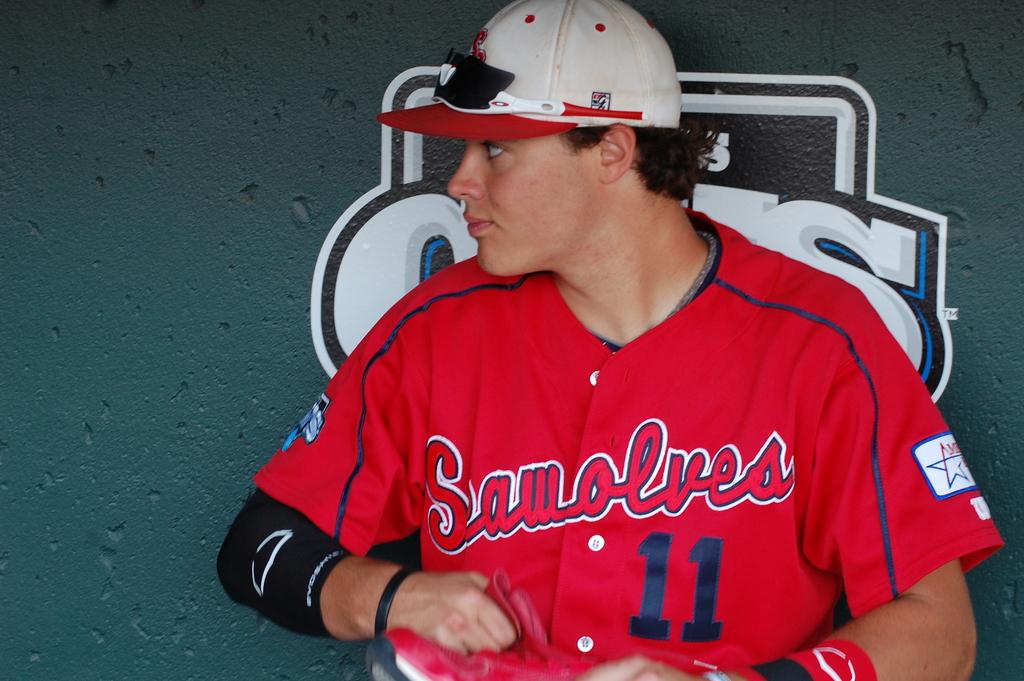What is the man in red team number?
Give a very brief answer. 11. What is the team name?
Your answer should be compact. Sawolves. 